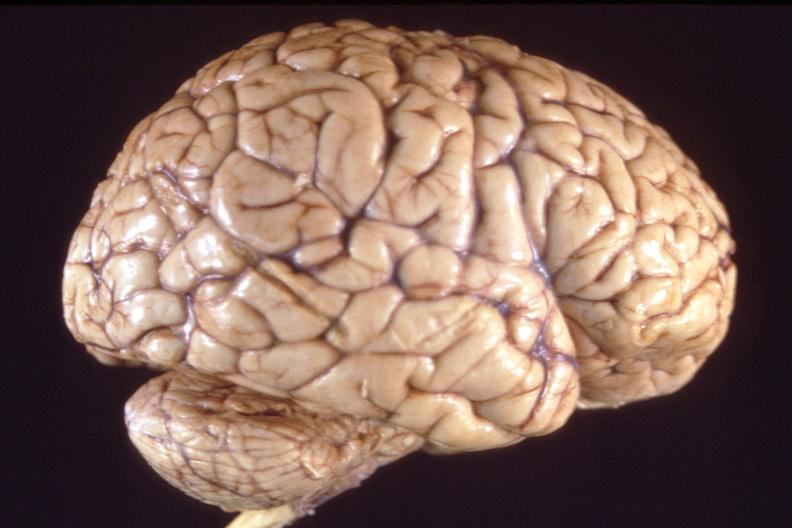what does this image show?
Answer the question using a single word or phrase. Brain 